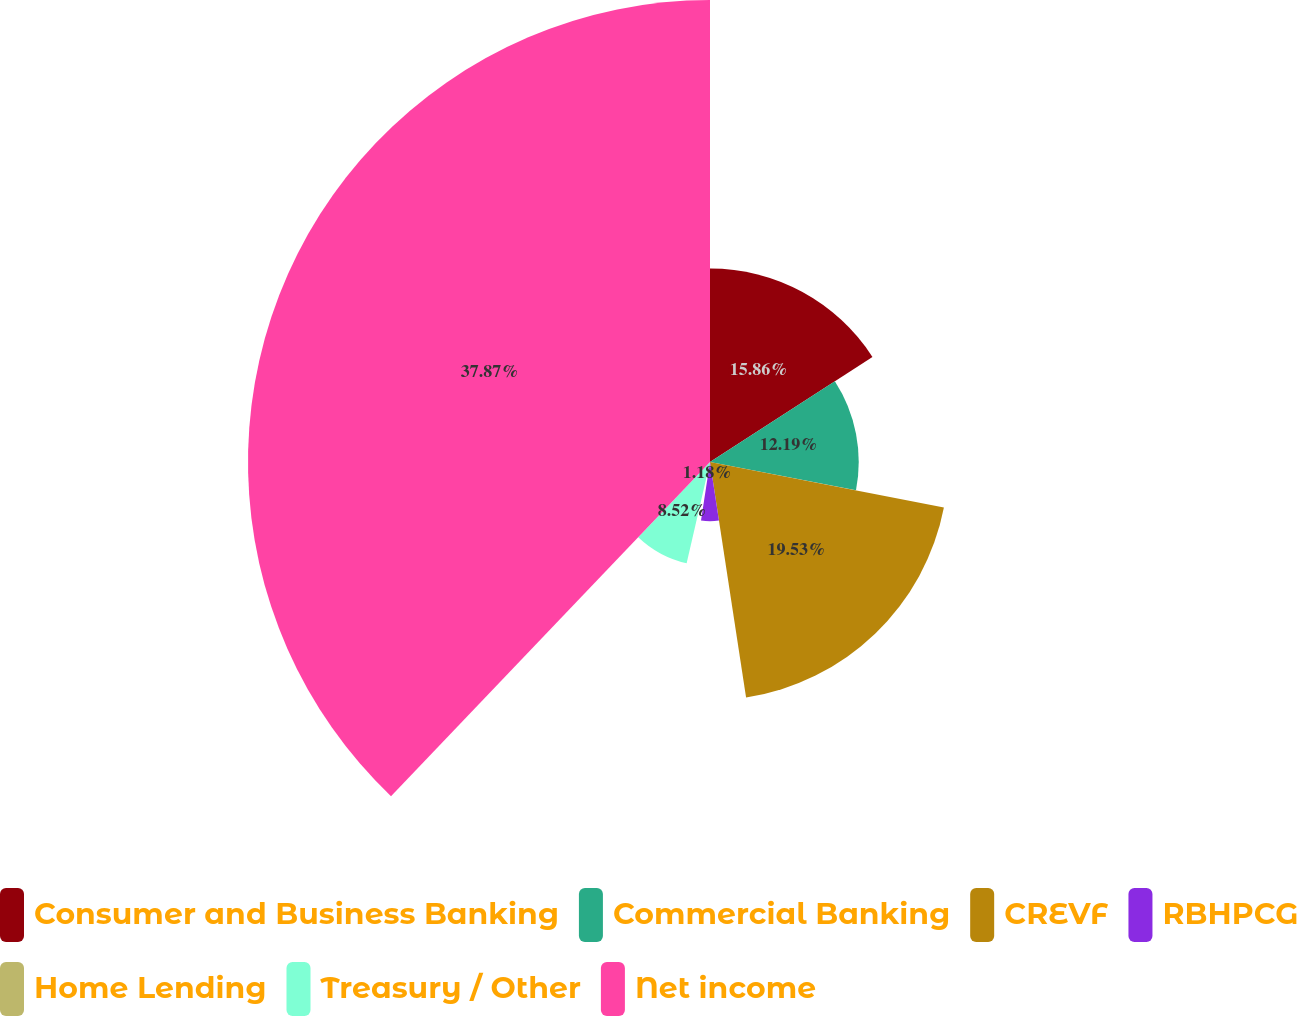Convert chart to OTSL. <chart><loc_0><loc_0><loc_500><loc_500><pie_chart><fcel>Consumer and Business Banking<fcel>Commercial Banking<fcel>CREVF<fcel>RBHPCG<fcel>Home Lending<fcel>Treasury / Other<fcel>Net income<nl><fcel>15.86%<fcel>12.19%<fcel>19.53%<fcel>4.85%<fcel>1.18%<fcel>8.52%<fcel>37.87%<nl></chart> 